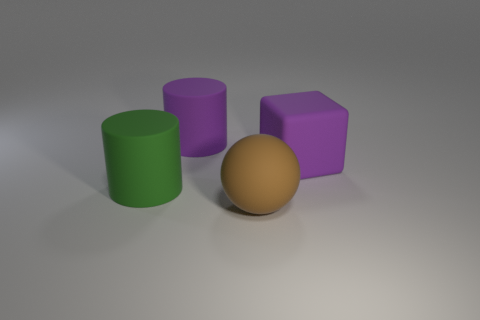Add 4 rubber cylinders. How many objects exist? 8 Subtract all spheres. How many objects are left? 3 Add 4 brown rubber spheres. How many brown rubber spheres are left? 5 Add 3 matte things. How many matte things exist? 7 Subtract 0 blue blocks. How many objects are left? 4 Subtract all big matte spheres. Subtract all rubber cubes. How many objects are left? 2 